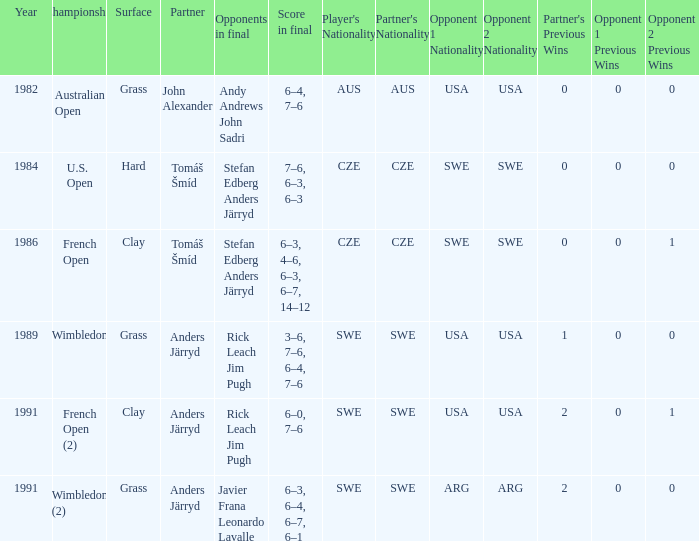Who was his partner in 1989?  Anders Järryd. 